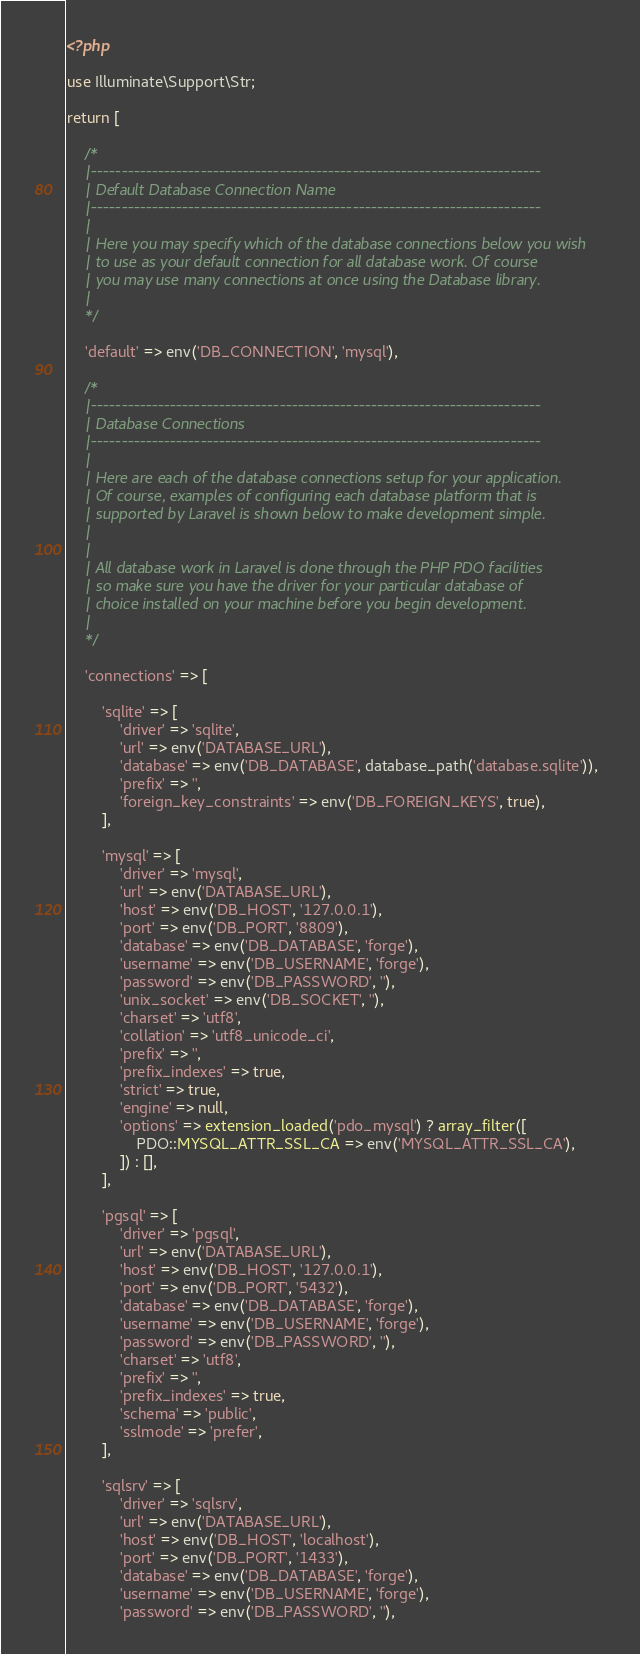<code> <loc_0><loc_0><loc_500><loc_500><_PHP_><?php

use Illuminate\Support\Str;

return [

    /*
    |--------------------------------------------------------------------------
    | Default Database Connection Name
    |--------------------------------------------------------------------------
    |
    | Here you may specify which of the database connections below you wish
    | to use as your default connection for all database work. Of course
    | you may use many connections at once using the Database library.
    |
    */

    'default' => env('DB_CONNECTION', 'mysql'),

    /*
    |--------------------------------------------------------------------------
    | Database Connections
    |--------------------------------------------------------------------------
    |
    | Here are each of the database connections setup for your application.
    | Of course, examples of configuring each database platform that is
    | supported by Laravel is shown below to make development simple.
    |
    |
    | All database work in Laravel is done through the PHP PDO facilities
    | so make sure you have the driver for your particular database of
    | choice installed on your machine before you begin development.
    |
    */

    'connections' => [

        'sqlite' => [
            'driver' => 'sqlite',
            'url' => env('DATABASE_URL'),
            'database' => env('DB_DATABASE', database_path('database.sqlite')),
            'prefix' => '',
            'foreign_key_constraints' => env('DB_FOREIGN_KEYS', true),
        ],

        'mysql' => [
            'driver' => 'mysql',
            'url' => env('DATABASE_URL'),
            'host' => env('DB_HOST', '127.0.0.1'),
            'port' => env('DB_PORT', '8809'),
            'database' => env('DB_DATABASE', 'forge'),
            'username' => env('DB_USERNAME', 'forge'),
            'password' => env('DB_PASSWORD', ''),
            'unix_socket' => env('DB_SOCKET', ''),
            'charset' => 'utf8',
            'collation' => 'utf8_unicode_ci',
            'prefix' => '',
            'prefix_indexes' => true,
            'strict' => true,
            'engine' => null,
            'options' => extension_loaded('pdo_mysql') ? array_filter([
                PDO::MYSQL_ATTR_SSL_CA => env('MYSQL_ATTR_SSL_CA'),
            ]) : [],
        ],

        'pgsql' => [
            'driver' => 'pgsql',
            'url' => env('DATABASE_URL'),
            'host' => env('DB_HOST', '127.0.0.1'),
            'port' => env('DB_PORT', '5432'),
            'database' => env('DB_DATABASE', 'forge'),
            'username' => env('DB_USERNAME', 'forge'),
            'password' => env('DB_PASSWORD', ''),
            'charset' => 'utf8',
            'prefix' => '',
            'prefix_indexes' => true,
            'schema' => 'public',
            'sslmode' => 'prefer',
        ],

        'sqlsrv' => [
            'driver' => 'sqlsrv',
            'url' => env('DATABASE_URL'),
            'host' => env('DB_HOST', 'localhost'),
            'port' => env('DB_PORT', '1433'),
            'database' => env('DB_DATABASE', 'forge'),
            'username' => env('DB_USERNAME', 'forge'),
            'password' => env('DB_PASSWORD', ''),</code> 